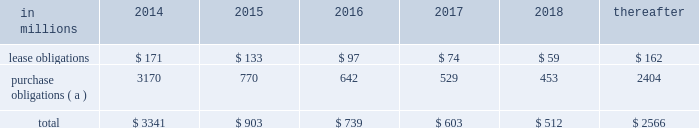At december 31 , 2013 , total future minimum commitments under existing non-cancelable operating leases and purchase obligations were as follows: .
( a ) includes $ 3.3 billion relating to fiber supply agreements entered into at the time of the company 2019s 2006 transformation plan forestland sales and in conjunction with the 2008 acquisition of weyerhaeuser company 2019s containerboard , packaging and recycling business .
Rent expense was $ 215 million , $ 231 million and $ 205 million for 2013 , 2012 and 2011 , respectively .
Guarantees in connection with sales of businesses , property , equipment , forestlands and other assets , international paper commonly makes representations and warranties relating to such businesses or assets , and may agree to indemnify buyers with respect to tax and environmental liabilities , breaches of representations and warranties , and other matters .
Where liabilities for such matters are determined to be probable and subject to reasonable estimation , accrued liabilities are recorded at the time of sale as a cost of the transaction .
Environmental proceedings international paper has been named as a potentially responsible party in environmental remediation actions under various federal and state laws , including the comprehensive environmental response , compensation and liability act ( cercla ) .
Many of these proceedings involve the cleanup of hazardous substances at large commercial landfills that received waste from many different sources .
While joint and several liability is authorized under cercla and equivalent state laws , as a practical matter , liability for cercla cleanups is typically allocated among the many potential responsible parties .
Remedial costs are recorded in the consolidated financial statements when they become probable and reasonably estimable .
International paper has estimated the probable liability associated with these matters to be approximately $ 94 million in the aggregate at december 31 , 2013 .
Cass lake : one of the matters referenced above is a closed wood treating facility located in cass lake , minnesota .
During 2009 , in connection with an environmental site remediation action under cercla , international paper submitted to the epa a site remediation feasibility study .
In june 2011 , the epa selected and published a proposed soil remedy at the site with an estimated cost of $ 46 million .
The overall remediation reserve for the site is currently $ 51 million to address this selection of an alternative for the soil remediation component of the overall site remedy .
In october 2011 , the epa released a public statement indicating that the final soil remedy decision would be delayed .
In the unlikely event that the epa changes its proposed soil remedy and approves instead a more expensive clean-up alternative , the remediation costs could be material , and significantly higher than amounts currently recorded .
In october 2012 , the natural resource trustees for this site provided notice to international paper and other potentially responsible parties of their intent to perform a natural resource damage assessment .
It is premature to predict the outcome of the assessment or to estimate a loss or range of loss , if any , which may be incurred .
Other : in addition to the above matters , other remediation costs typically associated with the cleanup of hazardous substances at the company 2019s current , closed or formerly-owned facilities , and recorded as liabilities in the balance sheet , totaled approximately $ 42 million at december 31 , 2013 .
Other than as described above , completion of required remedial actions is not expected to have a material effect on our consolidated financial statements .
Kalamazoo river : the company is a potentially responsible party with respect to the allied paper , inc./ portage creek/kalamazoo river superfund site ( kalamazoo river superfund site ) in michigan .
The epa asserts that the site is contaminated primarily by pcbs as a result of discharges from various paper mills located along the kalamazoo river , including a paper mill formerly owned by st .
Regis paper company ( st .
Regis ) .
The company is a successor in interest to st .
Regis .
The company has not received any orders from the epa with respect to the site and continues to collect information from the epa and other parties relative to the site to evaluate the extent of its liability , if any , with respect to the site .
Accordingly , it is premature to estimate a loss or range of loss with respect to this site .
Also in connection with the kalamazoo river superfund site , the company was named as a defendant by georgia-pacific consumer products lp , fort james corporation and georgia pacific llc in a contribution and cost recovery action for alleged pollution at the site .
The suit seeks contribution under cercla for $ 79 million in costs purportedly expended by plaintiffs as of the filing of the complaint and for future remediation costs .
The suit alleges that a mill , during the time it was allegedly owned and operated by st .
Regis , discharged pcb contaminated solids and paper residuals resulting from paper de-inking and recycling .
Also named as defendants in the suit are ncr corporation and weyerhaeuser company .
In mid-2011 , the suit was transferred from the district court for the eastern district of wisconsin to the district court for the western .
In 2014 what percentage of at december 31 , 2013 , total future minimum commitments under existing non-cancelable operating leases and purchase obligations is due to purchase obligations? 
Computations: (3170 / 3341)
Answer: 0.94882. 